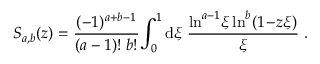Convert formula to latex. <formula><loc_0><loc_0><loc_500><loc_500>S _ { a , b } ( z ) = \frac { ( - 1 ) ^ { a + b - 1 } } { ( a - 1 ) ! \, b ! } \, \int _ { 0 } ^ { 1 } d \xi \, \frac { \ln ^ { a - 1 } \, \xi \ln ^ { b } ( 1 \, - \, z \xi ) } { \xi } \, .</formula> 